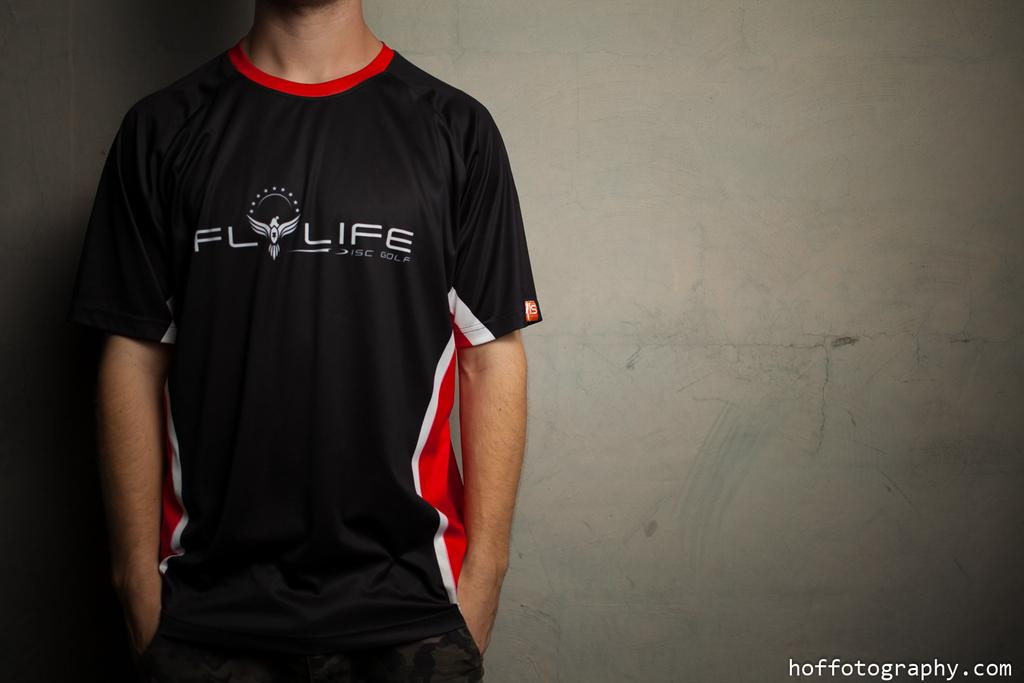<image>
Present a compact description of the photo's key features. A man stands against a wall wearing his disc golf uniform. 